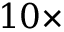Convert formula to latex. <formula><loc_0><loc_0><loc_500><loc_500>1 0 \times</formula> 